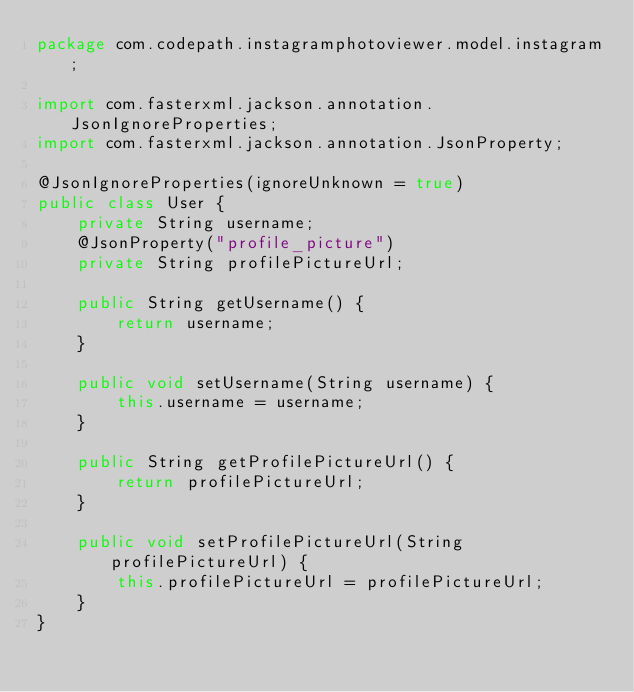Convert code to text. <code><loc_0><loc_0><loc_500><loc_500><_Java_>package com.codepath.instagramphotoviewer.model.instagram;

import com.fasterxml.jackson.annotation.JsonIgnoreProperties;
import com.fasterxml.jackson.annotation.JsonProperty;

@JsonIgnoreProperties(ignoreUnknown = true)
public class User {
    private String username;
    @JsonProperty("profile_picture")
    private String profilePictureUrl;

    public String getUsername() {
        return username;
    }

    public void setUsername(String username) {
        this.username = username;
    }

    public String getProfilePictureUrl() {
        return profilePictureUrl;
    }

    public void setProfilePictureUrl(String profilePictureUrl) {
        this.profilePictureUrl = profilePictureUrl;
    }
}
</code> 